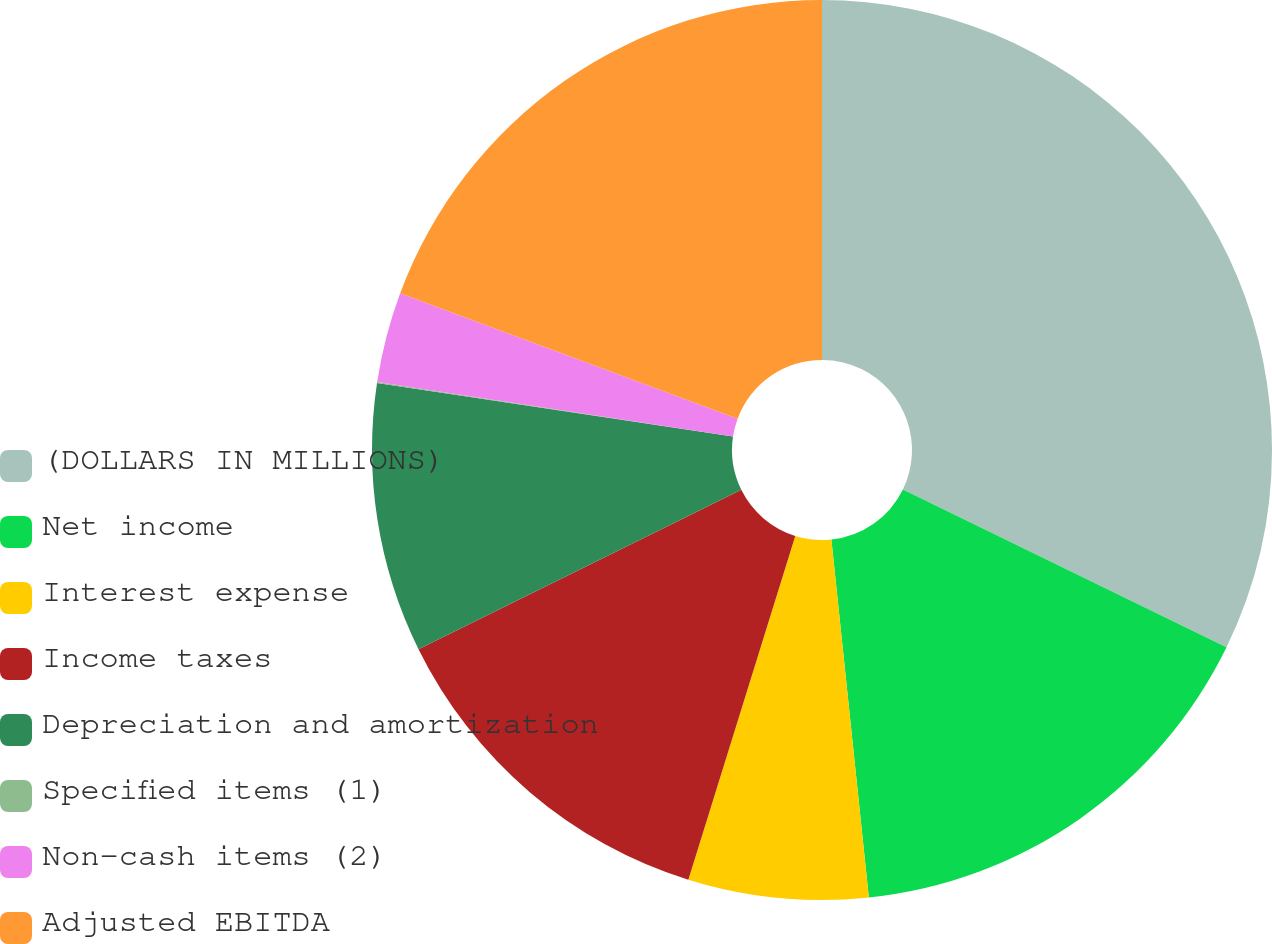<chart> <loc_0><loc_0><loc_500><loc_500><pie_chart><fcel>(DOLLARS IN MILLIONS)<fcel>Net income<fcel>Interest expense<fcel>Income taxes<fcel>Depreciation and amortization<fcel>Specified items (1)<fcel>Non-cash items (2)<fcel>Adjusted EBITDA<nl><fcel>32.22%<fcel>16.12%<fcel>6.46%<fcel>12.9%<fcel>9.68%<fcel>0.03%<fcel>3.25%<fcel>19.34%<nl></chart> 